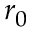Convert formula to latex. <formula><loc_0><loc_0><loc_500><loc_500>r _ { 0 }</formula> 